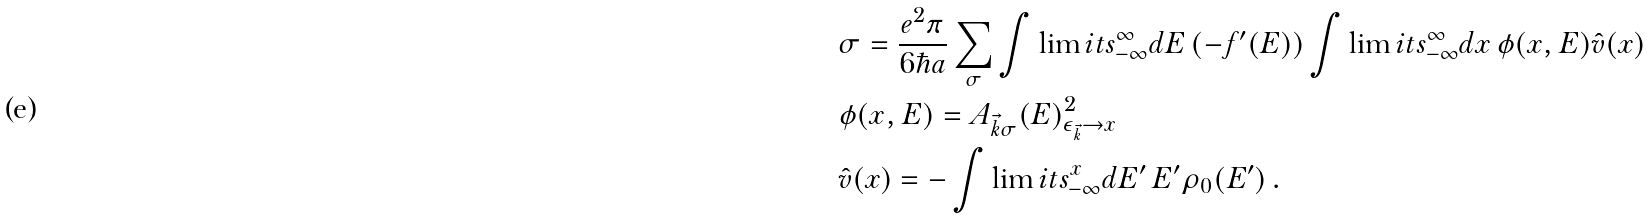<formula> <loc_0><loc_0><loc_500><loc_500>& \sigma = \frac { e ^ { 2 } \pi } { 6 \hbar { a } } \sum _ { \sigma } \int \lim i t s _ { - \infty } ^ { \infty } d E \, ( - f ^ { \prime } ( E ) ) \int \lim i t s _ { - \infty } ^ { \infty } d x \, \phi ( x , E ) \hat { v } ( x ) \\ & \phi ( x , E ) = A _ { \vec { k } \sigma } ( E ) ^ { 2 } _ { \epsilon _ { \vec { k } } \to x } \\ & \hat { v } ( x ) = - \int \lim i t s _ { - \infty } ^ { x } d E ^ { \prime } \, E ^ { \prime } \rho _ { 0 } ( E ^ { \prime } ) \, .</formula> 